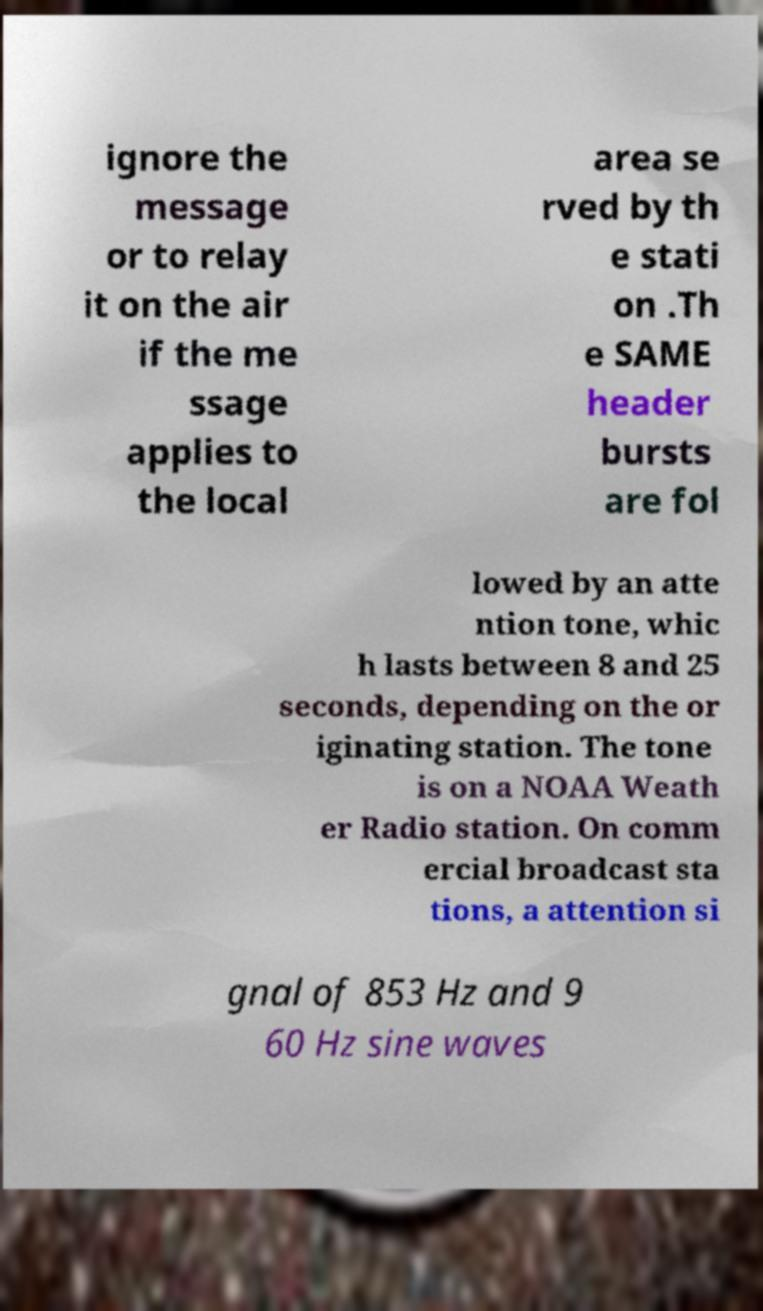Could you assist in decoding the text presented in this image and type it out clearly? ignore the message or to relay it on the air if the me ssage applies to the local area se rved by th e stati on .Th e SAME header bursts are fol lowed by an atte ntion tone, whic h lasts between 8 and 25 seconds, depending on the or iginating station. The tone is on a NOAA Weath er Radio station. On comm ercial broadcast sta tions, a attention si gnal of 853 Hz and 9 60 Hz sine waves 